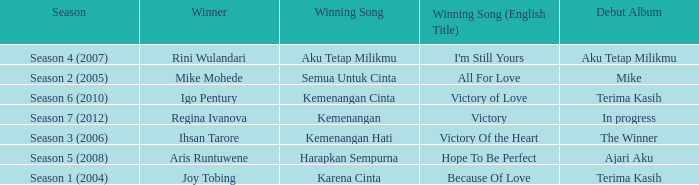Which winning song was sung by aku tetap milikmu? I'm Still Yours. 